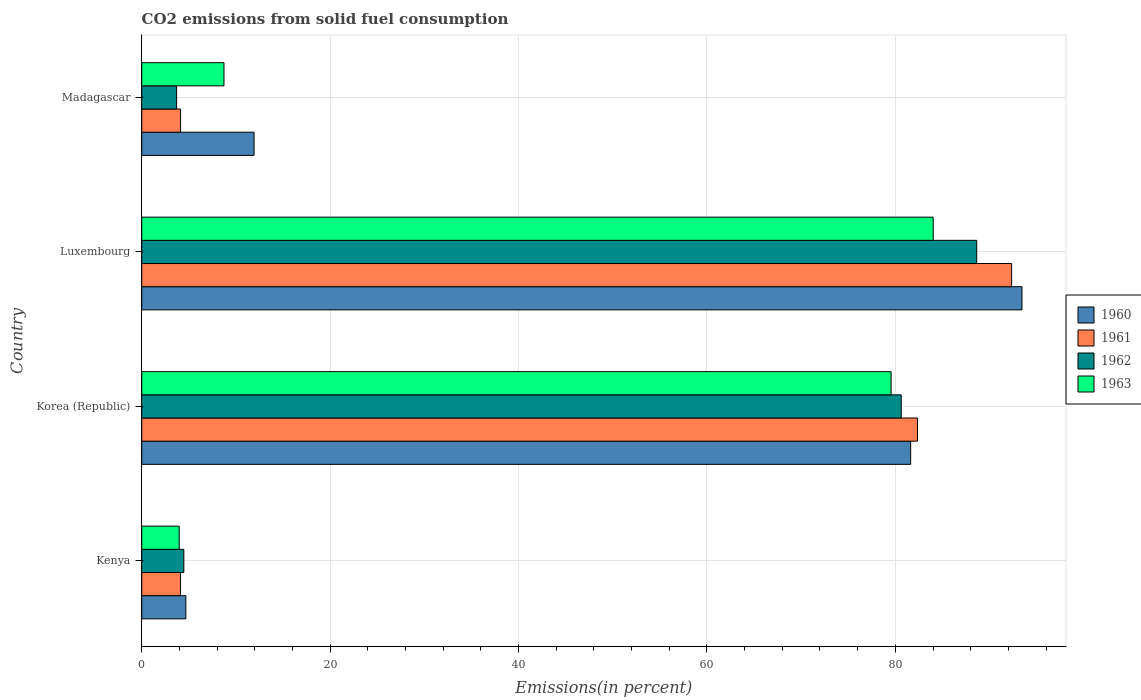How many groups of bars are there?
Provide a short and direct response. 4. How many bars are there on the 2nd tick from the bottom?
Your answer should be compact. 4. What is the label of the 4th group of bars from the top?
Provide a succinct answer. Kenya. What is the total CO2 emitted in 1961 in Kenya?
Give a very brief answer. 4.12. Across all countries, what is the maximum total CO2 emitted in 1960?
Your answer should be very brief. 93.44. Across all countries, what is the minimum total CO2 emitted in 1960?
Make the answer very short. 4.68. In which country was the total CO2 emitted in 1963 maximum?
Your response must be concise. Luxembourg. In which country was the total CO2 emitted in 1960 minimum?
Give a very brief answer. Kenya. What is the total total CO2 emitted in 1961 in the graph?
Your answer should be very brief. 182.94. What is the difference between the total CO2 emitted in 1961 in Korea (Republic) and that in Luxembourg?
Make the answer very short. -9.99. What is the difference between the total CO2 emitted in 1962 in Kenya and the total CO2 emitted in 1960 in Madagascar?
Your response must be concise. -7.46. What is the average total CO2 emitted in 1962 per country?
Provide a succinct answer. 44.36. What is the difference between the total CO2 emitted in 1963 and total CO2 emitted in 1960 in Korea (Republic)?
Give a very brief answer. -2.08. In how many countries, is the total CO2 emitted in 1960 greater than 84 %?
Your answer should be compact. 1. What is the ratio of the total CO2 emitted in 1960 in Kenya to that in Luxembourg?
Offer a very short reply. 0.05. Is the difference between the total CO2 emitted in 1963 in Kenya and Madagascar greater than the difference between the total CO2 emitted in 1960 in Kenya and Madagascar?
Give a very brief answer. Yes. What is the difference between the highest and the second highest total CO2 emitted in 1962?
Ensure brevity in your answer.  8.01. What is the difference between the highest and the lowest total CO2 emitted in 1963?
Your answer should be compact. 80.04. Is the sum of the total CO2 emitted in 1963 in Kenya and Madagascar greater than the maximum total CO2 emitted in 1962 across all countries?
Make the answer very short. No. Is it the case that in every country, the sum of the total CO2 emitted in 1962 and total CO2 emitted in 1963 is greater than the sum of total CO2 emitted in 1961 and total CO2 emitted in 1960?
Ensure brevity in your answer.  No. Is it the case that in every country, the sum of the total CO2 emitted in 1961 and total CO2 emitted in 1963 is greater than the total CO2 emitted in 1960?
Offer a terse response. Yes. How many bars are there?
Give a very brief answer. 16. Are all the bars in the graph horizontal?
Make the answer very short. Yes. How many countries are there in the graph?
Make the answer very short. 4. What is the difference between two consecutive major ticks on the X-axis?
Offer a terse response. 20. Does the graph contain grids?
Offer a very short reply. Yes. Where does the legend appear in the graph?
Your answer should be compact. Center right. How many legend labels are there?
Offer a very short reply. 4. What is the title of the graph?
Keep it short and to the point. CO2 emissions from solid fuel consumption. What is the label or title of the X-axis?
Your answer should be compact. Emissions(in percent). What is the label or title of the Y-axis?
Offer a very short reply. Country. What is the Emissions(in percent) in 1960 in Kenya?
Provide a succinct answer. 4.68. What is the Emissions(in percent) of 1961 in Kenya?
Make the answer very short. 4.12. What is the Emissions(in percent) in 1962 in Kenya?
Make the answer very short. 4.47. What is the Emissions(in percent) of 1963 in Kenya?
Your answer should be compact. 3.98. What is the Emissions(in percent) in 1960 in Korea (Republic)?
Your response must be concise. 81.62. What is the Emissions(in percent) of 1961 in Korea (Republic)?
Offer a very short reply. 82.35. What is the Emissions(in percent) of 1962 in Korea (Republic)?
Ensure brevity in your answer.  80.62. What is the Emissions(in percent) of 1963 in Korea (Republic)?
Make the answer very short. 79.55. What is the Emissions(in percent) of 1960 in Luxembourg?
Provide a succinct answer. 93.44. What is the Emissions(in percent) of 1961 in Luxembourg?
Make the answer very short. 92.34. What is the Emissions(in percent) in 1962 in Luxembourg?
Keep it short and to the point. 88.63. What is the Emissions(in percent) of 1963 in Luxembourg?
Ensure brevity in your answer.  84.02. What is the Emissions(in percent) in 1960 in Madagascar?
Offer a terse response. 11.93. What is the Emissions(in percent) of 1961 in Madagascar?
Your response must be concise. 4.12. What is the Emissions(in percent) of 1962 in Madagascar?
Provide a short and direct response. 3.7. What is the Emissions(in percent) in 1963 in Madagascar?
Your response must be concise. 8.73. Across all countries, what is the maximum Emissions(in percent) of 1960?
Ensure brevity in your answer.  93.44. Across all countries, what is the maximum Emissions(in percent) in 1961?
Provide a succinct answer. 92.34. Across all countries, what is the maximum Emissions(in percent) of 1962?
Offer a very short reply. 88.63. Across all countries, what is the maximum Emissions(in percent) in 1963?
Your response must be concise. 84.02. Across all countries, what is the minimum Emissions(in percent) in 1960?
Provide a succinct answer. 4.68. Across all countries, what is the minimum Emissions(in percent) in 1961?
Offer a very short reply. 4.12. Across all countries, what is the minimum Emissions(in percent) of 1962?
Ensure brevity in your answer.  3.7. Across all countries, what is the minimum Emissions(in percent) in 1963?
Provide a succinct answer. 3.98. What is the total Emissions(in percent) of 1960 in the graph?
Your response must be concise. 191.68. What is the total Emissions(in percent) of 1961 in the graph?
Offer a very short reply. 182.94. What is the total Emissions(in percent) in 1962 in the graph?
Ensure brevity in your answer.  177.43. What is the total Emissions(in percent) of 1963 in the graph?
Your response must be concise. 176.27. What is the difference between the Emissions(in percent) in 1960 in Kenya and that in Korea (Republic)?
Provide a succinct answer. -76.94. What is the difference between the Emissions(in percent) in 1961 in Kenya and that in Korea (Republic)?
Offer a very short reply. -78.23. What is the difference between the Emissions(in percent) of 1962 in Kenya and that in Korea (Republic)?
Your answer should be compact. -76.15. What is the difference between the Emissions(in percent) in 1963 in Kenya and that in Korea (Republic)?
Give a very brief answer. -75.57. What is the difference between the Emissions(in percent) in 1960 in Kenya and that in Luxembourg?
Offer a terse response. -88.76. What is the difference between the Emissions(in percent) in 1961 in Kenya and that in Luxembourg?
Offer a terse response. -88.22. What is the difference between the Emissions(in percent) of 1962 in Kenya and that in Luxembourg?
Make the answer very short. -84.17. What is the difference between the Emissions(in percent) of 1963 in Kenya and that in Luxembourg?
Your answer should be very brief. -80.04. What is the difference between the Emissions(in percent) of 1960 in Kenya and that in Madagascar?
Give a very brief answer. -7.24. What is the difference between the Emissions(in percent) of 1961 in Kenya and that in Madagascar?
Offer a very short reply. -0. What is the difference between the Emissions(in percent) in 1962 in Kenya and that in Madagascar?
Offer a terse response. 0.77. What is the difference between the Emissions(in percent) in 1963 in Kenya and that in Madagascar?
Make the answer very short. -4.75. What is the difference between the Emissions(in percent) of 1960 in Korea (Republic) and that in Luxembourg?
Provide a succinct answer. -11.82. What is the difference between the Emissions(in percent) in 1961 in Korea (Republic) and that in Luxembourg?
Offer a very short reply. -9.99. What is the difference between the Emissions(in percent) in 1962 in Korea (Republic) and that in Luxembourg?
Provide a succinct answer. -8.01. What is the difference between the Emissions(in percent) in 1963 in Korea (Republic) and that in Luxembourg?
Make the answer very short. -4.47. What is the difference between the Emissions(in percent) of 1960 in Korea (Republic) and that in Madagascar?
Your response must be concise. 69.7. What is the difference between the Emissions(in percent) of 1961 in Korea (Republic) and that in Madagascar?
Keep it short and to the point. 78.23. What is the difference between the Emissions(in percent) of 1962 in Korea (Republic) and that in Madagascar?
Provide a succinct answer. 76.92. What is the difference between the Emissions(in percent) of 1963 in Korea (Republic) and that in Madagascar?
Offer a very short reply. 70.82. What is the difference between the Emissions(in percent) of 1960 in Luxembourg and that in Madagascar?
Offer a terse response. 81.52. What is the difference between the Emissions(in percent) in 1961 in Luxembourg and that in Madagascar?
Ensure brevity in your answer.  88.22. What is the difference between the Emissions(in percent) in 1962 in Luxembourg and that in Madagascar?
Give a very brief answer. 84.93. What is the difference between the Emissions(in percent) of 1963 in Luxembourg and that in Madagascar?
Your answer should be compact. 75.29. What is the difference between the Emissions(in percent) in 1960 in Kenya and the Emissions(in percent) in 1961 in Korea (Republic)?
Provide a short and direct response. -77.67. What is the difference between the Emissions(in percent) in 1960 in Kenya and the Emissions(in percent) in 1962 in Korea (Republic)?
Offer a terse response. -75.94. What is the difference between the Emissions(in percent) of 1960 in Kenya and the Emissions(in percent) of 1963 in Korea (Republic)?
Your answer should be very brief. -74.87. What is the difference between the Emissions(in percent) in 1961 in Kenya and the Emissions(in percent) in 1962 in Korea (Republic)?
Your response must be concise. -76.5. What is the difference between the Emissions(in percent) in 1961 in Kenya and the Emissions(in percent) in 1963 in Korea (Republic)?
Offer a terse response. -75.43. What is the difference between the Emissions(in percent) of 1962 in Kenya and the Emissions(in percent) of 1963 in Korea (Republic)?
Provide a short and direct response. -75.08. What is the difference between the Emissions(in percent) in 1960 in Kenya and the Emissions(in percent) in 1961 in Luxembourg?
Provide a short and direct response. -87.66. What is the difference between the Emissions(in percent) in 1960 in Kenya and the Emissions(in percent) in 1962 in Luxembourg?
Provide a short and direct response. -83.95. What is the difference between the Emissions(in percent) of 1960 in Kenya and the Emissions(in percent) of 1963 in Luxembourg?
Ensure brevity in your answer.  -79.33. What is the difference between the Emissions(in percent) of 1961 in Kenya and the Emissions(in percent) of 1962 in Luxembourg?
Offer a very short reply. -84.51. What is the difference between the Emissions(in percent) in 1961 in Kenya and the Emissions(in percent) in 1963 in Luxembourg?
Ensure brevity in your answer.  -79.89. What is the difference between the Emissions(in percent) in 1962 in Kenya and the Emissions(in percent) in 1963 in Luxembourg?
Ensure brevity in your answer.  -79.55. What is the difference between the Emissions(in percent) of 1960 in Kenya and the Emissions(in percent) of 1961 in Madagascar?
Provide a short and direct response. 0.56. What is the difference between the Emissions(in percent) of 1960 in Kenya and the Emissions(in percent) of 1962 in Madagascar?
Offer a very short reply. 0.98. What is the difference between the Emissions(in percent) of 1960 in Kenya and the Emissions(in percent) of 1963 in Madagascar?
Offer a very short reply. -4.05. What is the difference between the Emissions(in percent) of 1961 in Kenya and the Emissions(in percent) of 1962 in Madagascar?
Offer a terse response. 0.42. What is the difference between the Emissions(in percent) of 1961 in Kenya and the Emissions(in percent) of 1963 in Madagascar?
Offer a terse response. -4.61. What is the difference between the Emissions(in percent) of 1962 in Kenya and the Emissions(in percent) of 1963 in Madagascar?
Ensure brevity in your answer.  -4.26. What is the difference between the Emissions(in percent) in 1960 in Korea (Republic) and the Emissions(in percent) in 1961 in Luxembourg?
Offer a very short reply. -10.72. What is the difference between the Emissions(in percent) in 1960 in Korea (Republic) and the Emissions(in percent) in 1962 in Luxembourg?
Give a very brief answer. -7.01. What is the difference between the Emissions(in percent) of 1960 in Korea (Republic) and the Emissions(in percent) of 1963 in Luxembourg?
Your answer should be very brief. -2.39. What is the difference between the Emissions(in percent) in 1961 in Korea (Republic) and the Emissions(in percent) in 1962 in Luxembourg?
Make the answer very short. -6.28. What is the difference between the Emissions(in percent) of 1961 in Korea (Republic) and the Emissions(in percent) of 1963 in Luxembourg?
Make the answer very short. -1.66. What is the difference between the Emissions(in percent) of 1962 in Korea (Republic) and the Emissions(in percent) of 1963 in Luxembourg?
Make the answer very short. -3.39. What is the difference between the Emissions(in percent) in 1960 in Korea (Republic) and the Emissions(in percent) in 1961 in Madagascar?
Provide a succinct answer. 77.5. What is the difference between the Emissions(in percent) in 1960 in Korea (Republic) and the Emissions(in percent) in 1962 in Madagascar?
Offer a terse response. 77.92. What is the difference between the Emissions(in percent) in 1960 in Korea (Republic) and the Emissions(in percent) in 1963 in Madagascar?
Provide a short and direct response. 72.89. What is the difference between the Emissions(in percent) of 1961 in Korea (Republic) and the Emissions(in percent) of 1962 in Madagascar?
Make the answer very short. 78.65. What is the difference between the Emissions(in percent) in 1961 in Korea (Republic) and the Emissions(in percent) in 1963 in Madagascar?
Your answer should be very brief. 73.62. What is the difference between the Emissions(in percent) in 1962 in Korea (Republic) and the Emissions(in percent) in 1963 in Madagascar?
Offer a very short reply. 71.89. What is the difference between the Emissions(in percent) of 1960 in Luxembourg and the Emissions(in percent) of 1961 in Madagascar?
Your response must be concise. 89.32. What is the difference between the Emissions(in percent) in 1960 in Luxembourg and the Emissions(in percent) in 1962 in Madagascar?
Ensure brevity in your answer.  89.74. What is the difference between the Emissions(in percent) in 1960 in Luxembourg and the Emissions(in percent) in 1963 in Madagascar?
Your answer should be compact. 84.71. What is the difference between the Emissions(in percent) of 1961 in Luxembourg and the Emissions(in percent) of 1962 in Madagascar?
Your answer should be very brief. 88.64. What is the difference between the Emissions(in percent) of 1961 in Luxembourg and the Emissions(in percent) of 1963 in Madagascar?
Provide a short and direct response. 83.61. What is the difference between the Emissions(in percent) of 1962 in Luxembourg and the Emissions(in percent) of 1963 in Madagascar?
Provide a succinct answer. 79.9. What is the average Emissions(in percent) of 1960 per country?
Keep it short and to the point. 47.92. What is the average Emissions(in percent) in 1961 per country?
Provide a succinct answer. 45.74. What is the average Emissions(in percent) in 1962 per country?
Make the answer very short. 44.36. What is the average Emissions(in percent) in 1963 per country?
Your response must be concise. 44.07. What is the difference between the Emissions(in percent) of 1960 and Emissions(in percent) of 1961 in Kenya?
Ensure brevity in your answer.  0.56. What is the difference between the Emissions(in percent) in 1960 and Emissions(in percent) in 1962 in Kenya?
Your answer should be very brief. 0.21. What is the difference between the Emissions(in percent) in 1960 and Emissions(in percent) in 1963 in Kenya?
Keep it short and to the point. 0.7. What is the difference between the Emissions(in percent) in 1961 and Emissions(in percent) in 1962 in Kenya?
Keep it short and to the point. -0.35. What is the difference between the Emissions(in percent) of 1961 and Emissions(in percent) of 1963 in Kenya?
Make the answer very short. 0.14. What is the difference between the Emissions(in percent) in 1962 and Emissions(in percent) in 1963 in Kenya?
Offer a terse response. 0.49. What is the difference between the Emissions(in percent) of 1960 and Emissions(in percent) of 1961 in Korea (Republic)?
Make the answer very short. -0.73. What is the difference between the Emissions(in percent) in 1960 and Emissions(in percent) in 1963 in Korea (Republic)?
Offer a very short reply. 2.08. What is the difference between the Emissions(in percent) of 1961 and Emissions(in percent) of 1962 in Korea (Republic)?
Your answer should be compact. 1.73. What is the difference between the Emissions(in percent) of 1961 and Emissions(in percent) of 1963 in Korea (Republic)?
Your response must be concise. 2.8. What is the difference between the Emissions(in percent) of 1962 and Emissions(in percent) of 1963 in Korea (Republic)?
Your answer should be very brief. 1.08. What is the difference between the Emissions(in percent) of 1960 and Emissions(in percent) of 1961 in Luxembourg?
Offer a very short reply. 1.1. What is the difference between the Emissions(in percent) in 1960 and Emissions(in percent) in 1962 in Luxembourg?
Keep it short and to the point. 4.81. What is the difference between the Emissions(in percent) in 1960 and Emissions(in percent) in 1963 in Luxembourg?
Your answer should be compact. 9.42. What is the difference between the Emissions(in percent) in 1961 and Emissions(in percent) in 1962 in Luxembourg?
Your answer should be compact. 3.71. What is the difference between the Emissions(in percent) in 1961 and Emissions(in percent) in 1963 in Luxembourg?
Give a very brief answer. 8.33. What is the difference between the Emissions(in percent) of 1962 and Emissions(in percent) of 1963 in Luxembourg?
Provide a succinct answer. 4.62. What is the difference between the Emissions(in percent) of 1960 and Emissions(in percent) of 1961 in Madagascar?
Your response must be concise. 7.8. What is the difference between the Emissions(in percent) of 1960 and Emissions(in percent) of 1962 in Madagascar?
Offer a terse response. 8.22. What is the difference between the Emissions(in percent) of 1960 and Emissions(in percent) of 1963 in Madagascar?
Give a very brief answer. 3.2. What is the difference between the Emissions(in percent) in 1961 and Emissions(in percent) in 1962 in Madagascar?
Keep it short and to the point. 0.42. What is the difference between the Emissions(in percent) in 1961 and Emissions(in percent) in 1963 in Madagascar?
Provide a short and direct response. -4.61. What is the difference between the Emissions(in percent) of 1962 and Emissions(in percent) of 1963 in Madagascar?
Your answer should be very brief. -5.03. What is the ratio of the Emissions(in percent) in 1960 in Kenya to that in Korea (Republic)?
Your response must be concise. 0.06. What is the ratio of the Emissions(in percent) in 1961 in Kenya to that in Korea (Republic)?
Your answer should be very brief. 0.05. What is the ratio of the Emissions(in percent) of 1962 in Kenya to that in Korea (Republic)?
Offer a terse response. 0.06. What is the ratio of the Emissions(in percent) of 1963 in Kenya to that in Korea (Republic)?
Your answer should be compact. 0.05. What is the ratio of the Emissions(in percent) of 1960 in Kenya to that in Luxembourg?
Give a very brief answer. 0.05. What is the ratio of the Emissions(in percent) of 1961 in Kenya to that in Luxembourg?
Offer a terse response. 0.04. What is the ratio of the Emissions(in percent) in 1962 in Kenya to that in Luxembourg?
Your answer should be very brief. 0.05. What is the ratio of the Emissions(in percent) in 1963 in Kenya to that in Luxembourg?
Your response must be concise. 0.05. What is the ratio of the Emissions(in percent) in 1960 in Kenya to that in Madagascar?
Your response must be concise. 0.39. What is the ratio of the Emissions(in percent) of 1961 in Kenya to that in Madagascar?
Provide a succinct answer. 1. What is the ratio of the Emissions(in percent) of 1962 in Kenya to that in Madagascar?
Keep it short and to the point. 1.21. What is the ratio of the Emissions(in percent) in 1963 in Kenya to that in Madagascar?
Your answer should be compact. 0.46. What is the ratio of the Emissions(in percent) of 1960 in Korea (Republic) to that in Luxembourg?
Ensure brevity in your answer.  0.87. What is the ratio of the Emissions(in percent) of 1961 in Korea (Republic) to that in Luxembourg?
Provide a short and direct response. 0.89. What is the ratio of the Emissions(in percent) of 1962 in Korea (Republic) to that in Luxembourg?
Keep it short and to the point. 0.91. What is the ratio of the Emissions(in percent) of 1963 in Korea (Republic) to that in Luxembourg?
Your answer should be compact. 0.95. What is the ratio of the Emissions(in percent) of 1960 in Korea (Republic) to that in Madagascar?
Your answer should be compact. 6.84. What is the ratio of the Emissions(in percent) of 1961 in Korea (Republic) to that in Madagascar?
Your answer should be compact. 19.97. What is the ratio of the Emissions(in percent) in 1962 in Korea (Republic) to that in Madagascar?
Your answer should be compact. 21.77. What is the ratio of the Emissions(in percent) in 1963 in Korea (Republic) to that in Madagascar?
Your answer should be very brief. 9.11. What is the ratio of the Emissions(in percent) in 1960 in Luxembourg to that in Madagascar?
Give a very brief answer. 7.83. What is the ratio of the Emissions(in percent) of 1961 in Luxembourg to that in Madagascar?
Provide a short and direct response. 22.39. What is the ratio of the Emissions(in percent) of 1962 in Luxembourg to that in Madagascar?
Ensure brevity in your answer.  23.93. What is the ratio of the Emissions(in percent) of 1963 in Luxembourg to that in Madagascar?
Keep it short and to the point. 9.62. What is the difference between the highest and the second highest Emissions(in percent) in 1960?
Keep it short and to the point. 11.82. What is the difference between the highest and the second highest Emissions(in percent) in 1961?
Make the answer very short. 9.99. What is the difference between the highest and the second highest Emissions(in percent) of 1962?
Offer a terse response. 8.01. What is the difference between the highest and the second highest Emissions(in percent) of 1963?
Make the answer very short. 4.47. What is the difference between the highest and the lowest Emissions(in percent) in 1960?
Provide a succinct answer. 88.76. What is the difference between the highest and the lowest Emissions(in percent) in 1961?
Your answer should be compact. 88.22. What is the difference between the highest and the lowest Emissions(in percent) of 1962?
Ensure brevity in your answer.  84.93. What is the difference between the highest and the lowest Emissions(in percent) of 1963?
Provide a short and direct response. 80.04. 